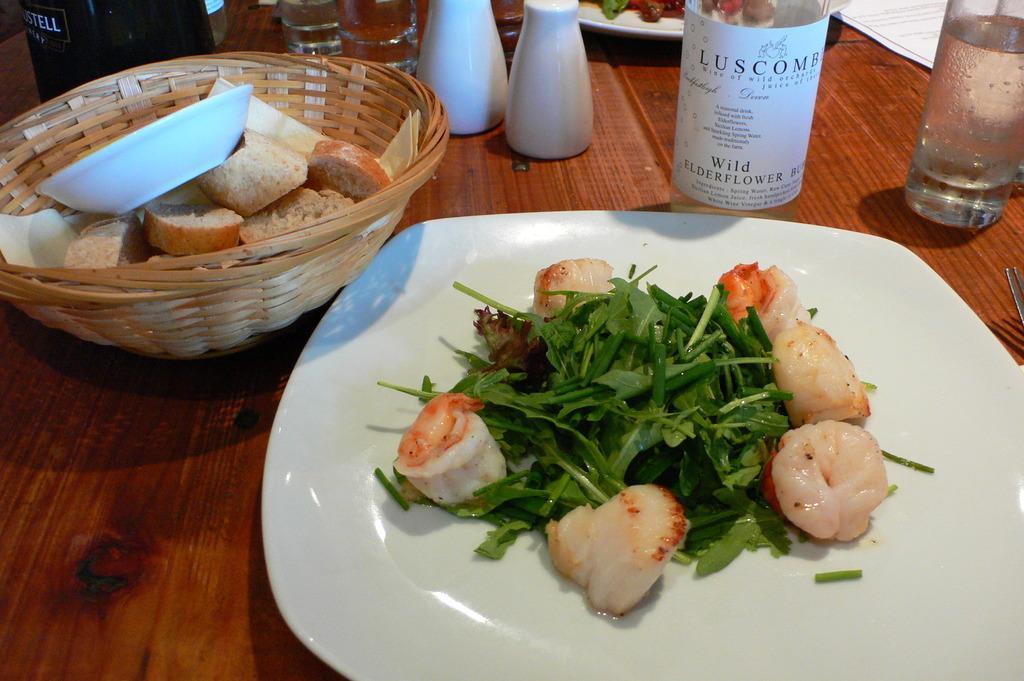Could you give a brief overview of what you see in this image? These are the food items in a white color plate, on the left side there are bread pieces in a basket. 